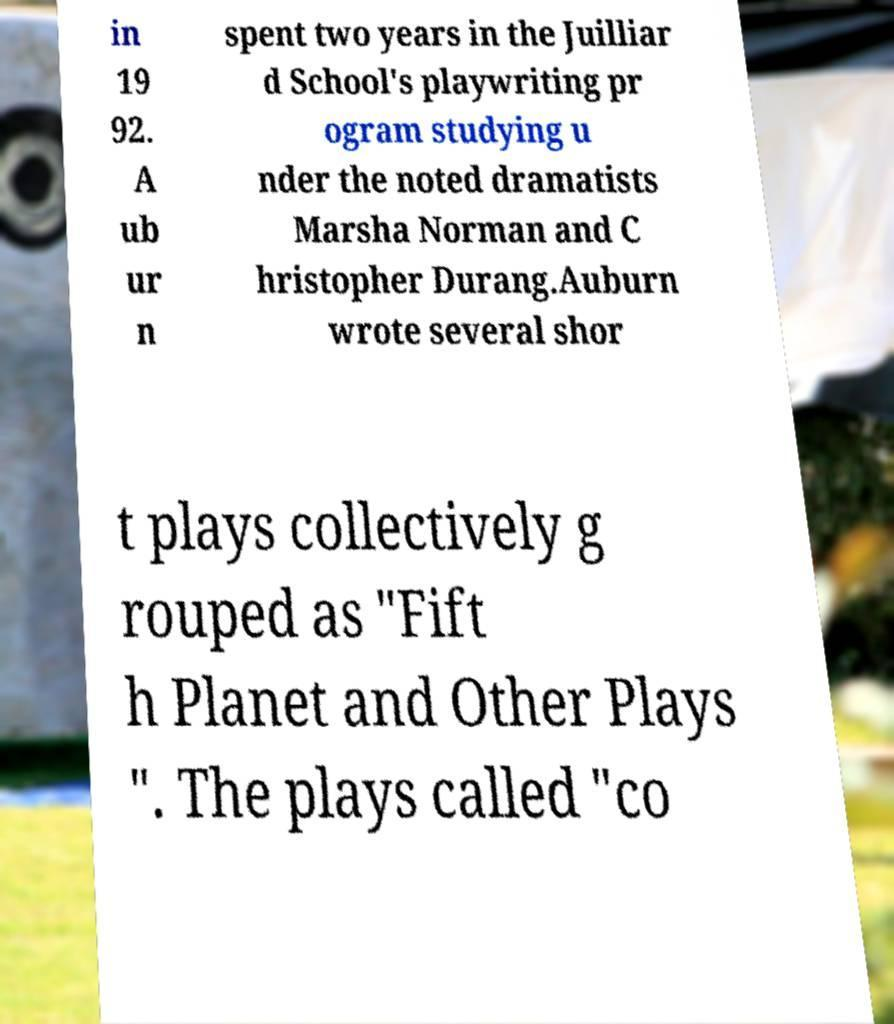Please read and relay the text visible in this image. What does it say? in 19 92. A ub ur n spent two years in the Juilliar d School's playwriting pr ogram studying u nder the noted dramatists Marsha Norman and C hristopher Durang.Auburn wrote several shor t plays collectively g rouped as "Fift h Planet and Other Plays ". The plays called "co 